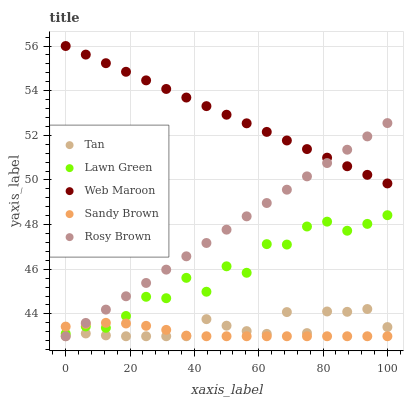Does Sandy Brown have the minimum area under the curve?
Answer yes or no. Yes. Does Web Maroon have the maximum area under the curve?
Answer yes or no. Yes. Does Tan have the minimum area under the curve?
Answer yes or no. No. Does Tan have the maximum area under the curve?
Answer yes or no. No. Is Web Maroon the smoothest?
Answer yes or no. Yes. Is Lawn Green the roughest?
Answer yes or no. Yes. Is Tan the smoothest?
Answer yes or no. No. Is Tan the roughest?
Answer yes or no. No. Does Tan have the lowest value?
Answer yes or no. Yes. Does Web Maroon have the lowest value?
Answer yes or no. No. Does Web Maroon have the highest value?
Answer yes or no. Yes. Does Tan have the highest value?
Answer yes or no. No. Is Tan less than Lawn Green?
Answer yes or no. Yes. Is Web Maroon greater than Lawn Green?
Answer yes or no. Yes. Does Rosy Brown intersect Tan?
Answer yes or no. Yes. Is Rosy Brown less than Tan?
Answer yes or no. No. Is Rosy Brown greater than Tan?
Answer yes or no. No. Does Tan intersect Lawn Green?
Answer yes or no. No. 